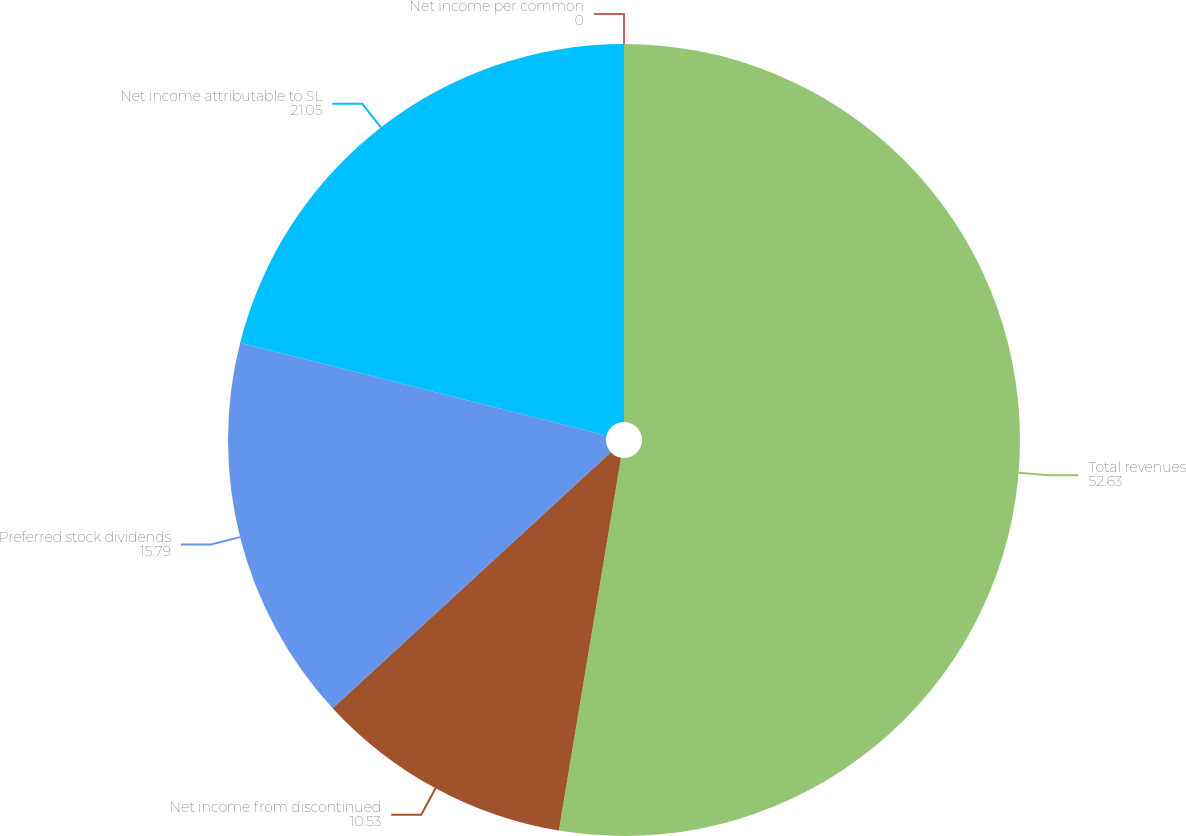<chart> <loc_0><loc_0><loc_500><loc_500><pie_chart><fcel>Total revenues<fcel>Net income from discontinued<fcel>Preferred stock dividends<fcel>Net income attributable to SL<fcel>Net income per common<nl><fcel>52.63%<fcel>10.53%<fcel>15.79%<fcel>21.05%<fcel>0.0%<nl></chart> 